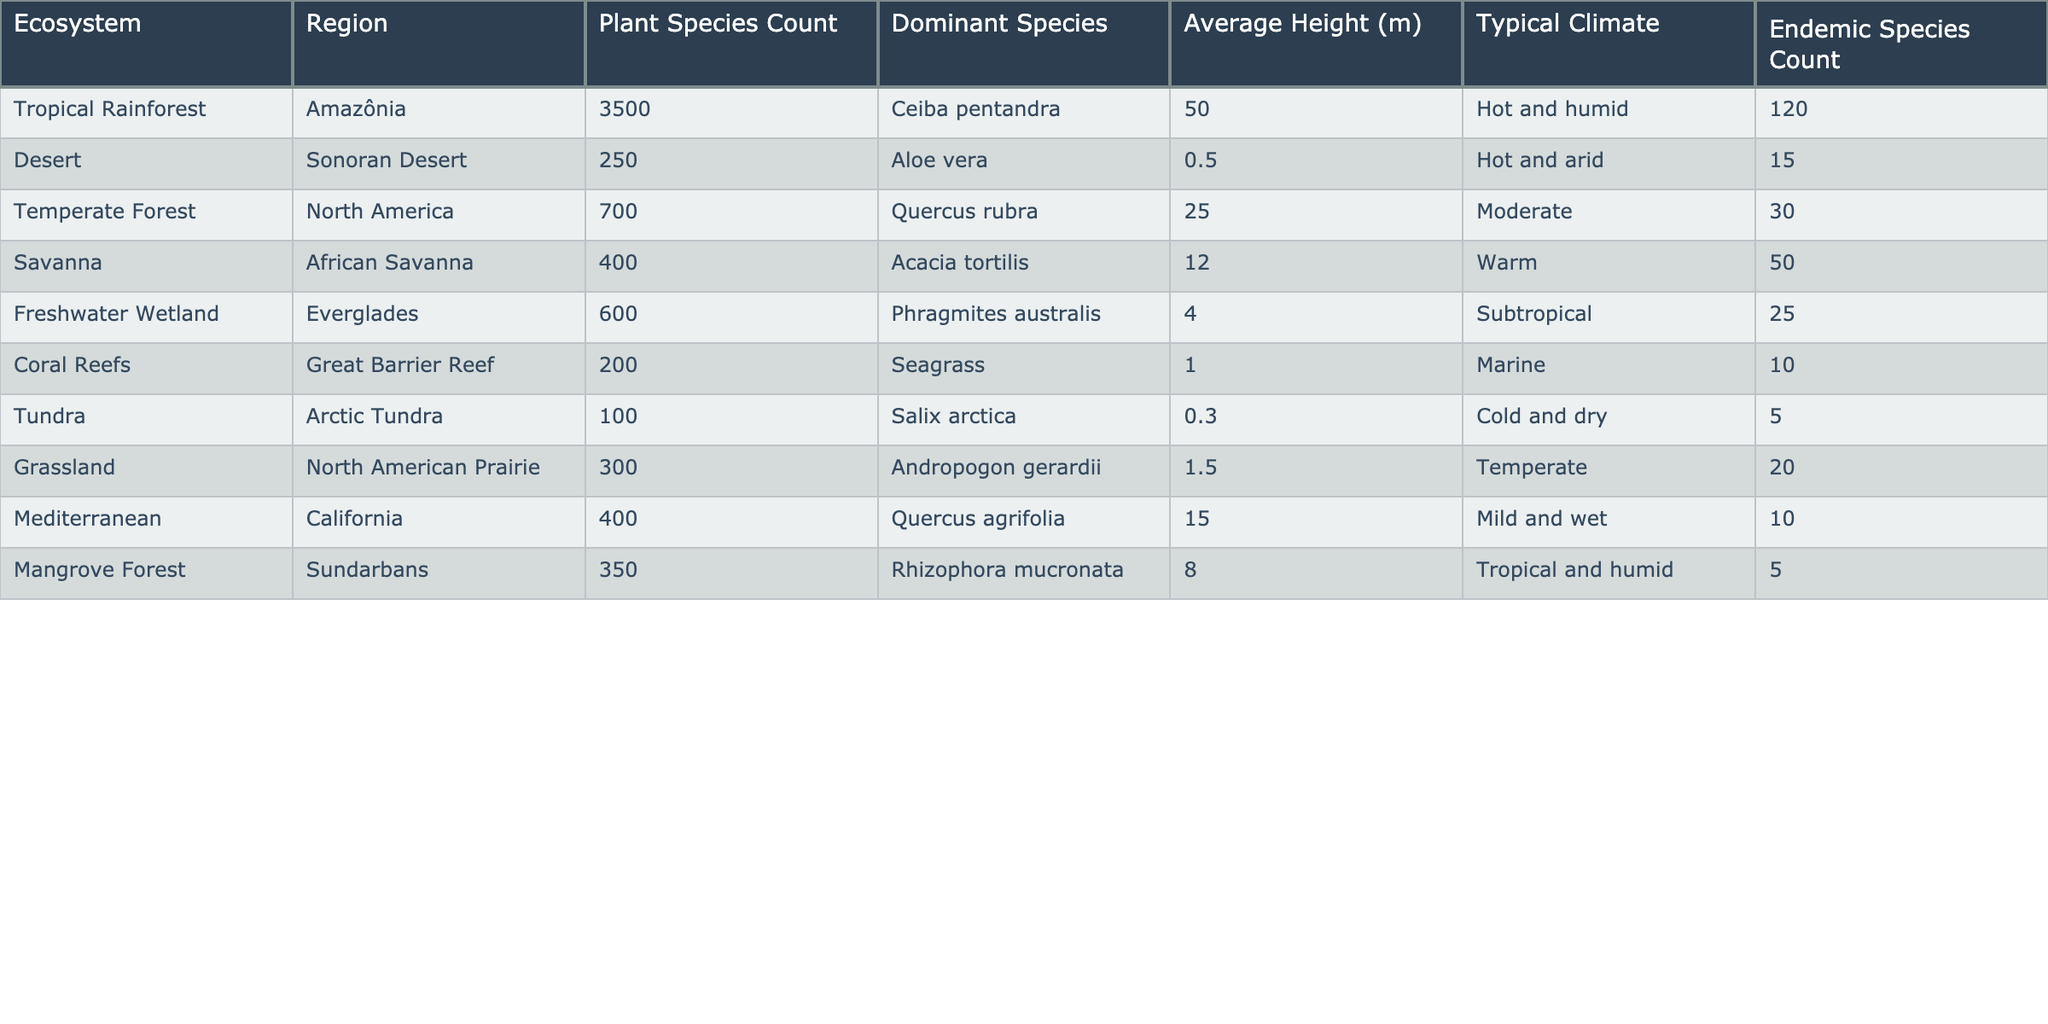What is the dominant species in the Tropical Rainforest? The table lists "Ceiba pentandra" as the dominant species in the Tropical Rainforest ecosystem under the "Dominant Species" column.
Answer: Ceiba pentandra How many plant species are found in the Desert ecosystem? According to the table, the count of plant species in the Desert ecosystem is listed as 250 in the "Plant Species Count" column.
Answer: 250 Which ecosystem has the highest average height of plants? The "Average Height" column shows that the Tropical Rainforest has the highest average height at 50 meters, which is greater than all other ecosystems.
Answer: 50 meters What is the total count of endemic species in both the Tropical Rainforest and Mangrove Forest? Add the values of endemic species for these two ecosystems: 120 (Tropical Rainforest) + 5 (Mangrove Forest) = 125.
Answer: 125 Is the typical climate for the Coral Reefs ecosystem marine? The table clearly states that the typical climate for the Coral Reefs ecosystem is "Marine," confirming that this statement is true.
Answer: Yes Which ecosystem has the most endemic species? Checking the "Endemic Species Count" column, the Tropical Rainforest has the highest count of 120 endemic species when compared to other ecosystems.
Answer: Tropical Rainforest What is the difference in plant species count between Tropical Rainforest and Temperate Forest? The difference is calculated as 3500 (Tropical Rainforest) - 700 (Temperate Forest) = 2800.
Answer: 2800 Which ecosystem has the lowest average height, and what is that height? The "Average Height" column indicates that the Tundra ecosystem has the lowest average height of 0.3 meters, which is less than any other ecosystem listed.
Answer: 0.3 meters How many ecosystems have more than 400 plant species? From the table, the ecosystems with more than 400 plant species are Tropical Rainforest, Freshwater Wetland, and African Savanna, totaling three ecosystems.
Answer: 3 Are there more endemic species in Temperate Forest than in Desert? The table shows the Temperate Forest has 30 endemic species, while the Desert has 15, confirming that the Temperate Forest has more.
Answer: Yes 